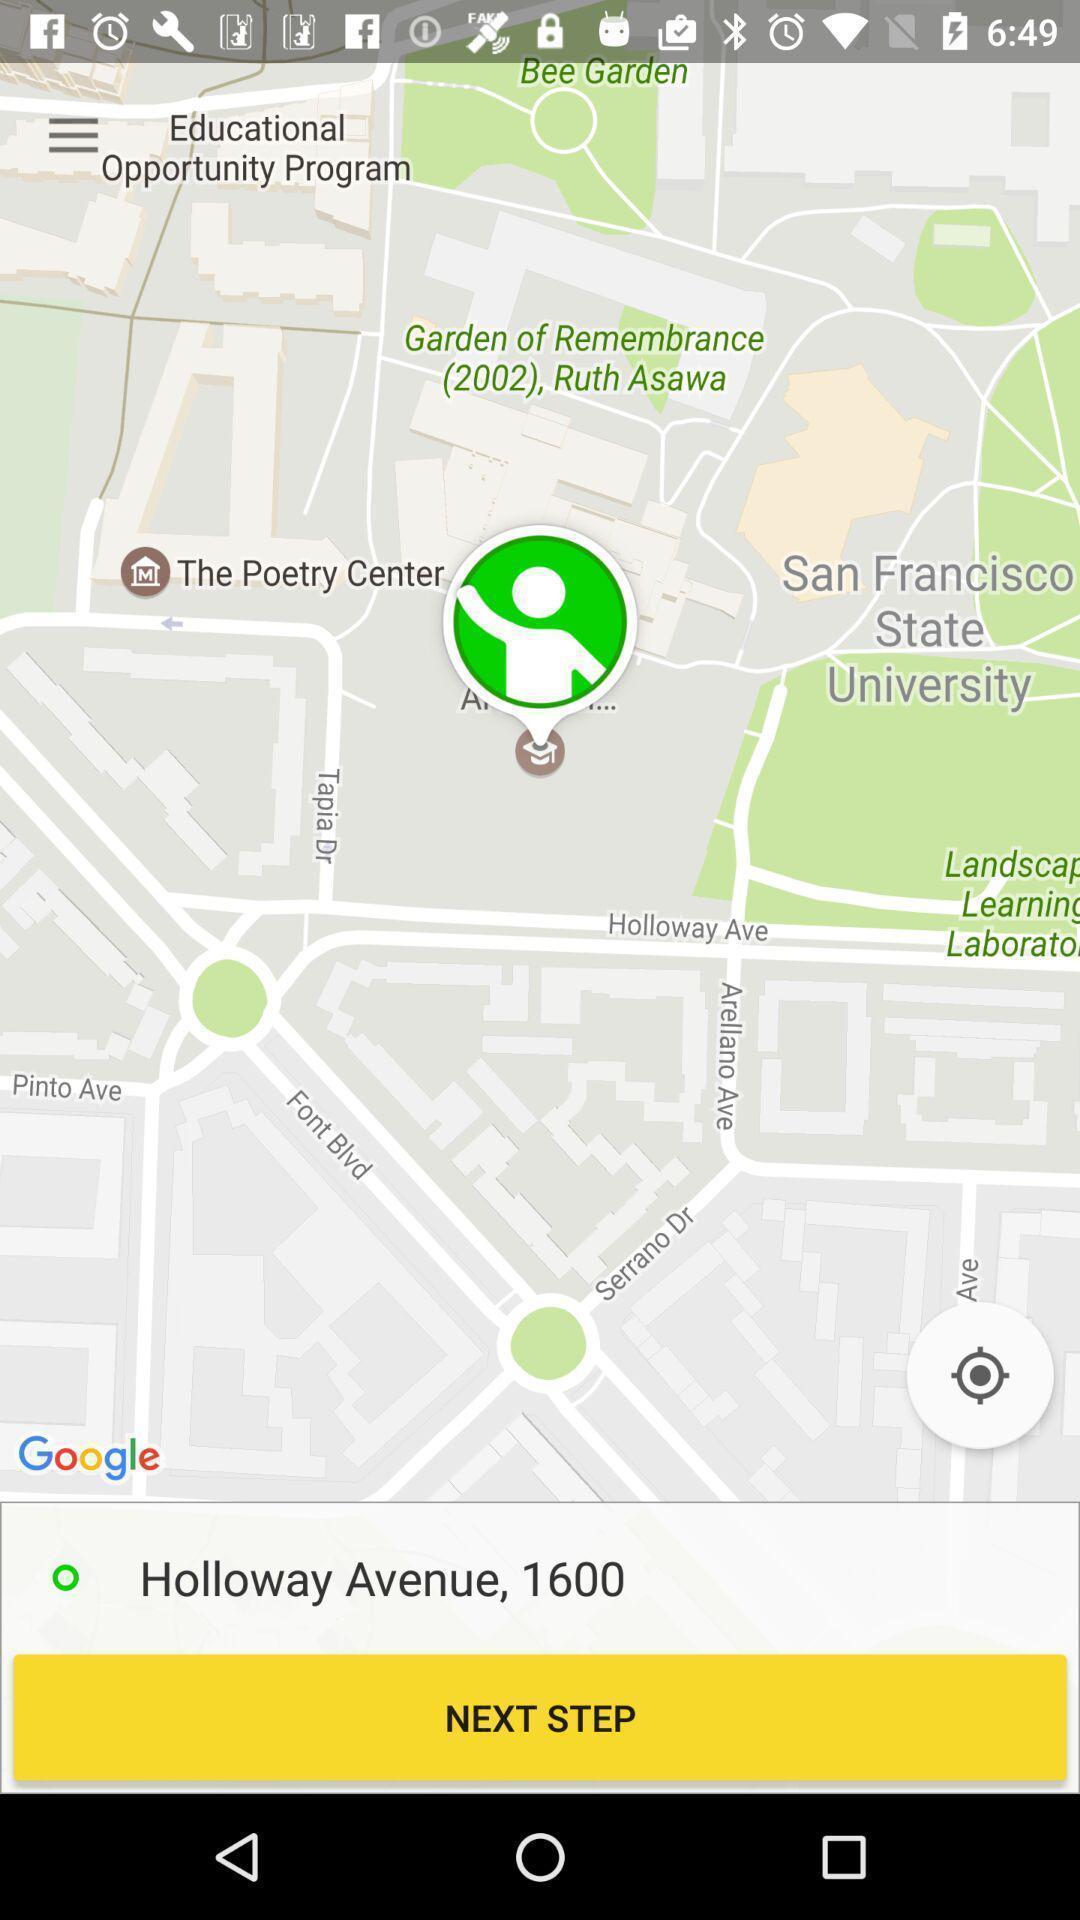What can you discern from this picture? Page showing location in map. 